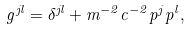<formula> <loc_0><loc_0><loc_500><loc_500>g ^ { j l } = \delta ^ { j l } + m ^ { - 2 } c ^ { - 2 } p ^ { j } p ^ { l } ,</formula> 